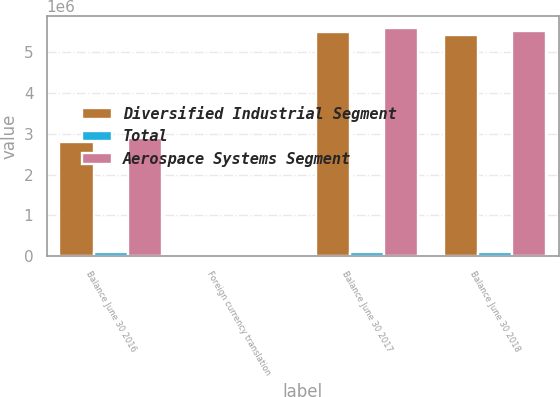Convert chart to OTSL. <chart><loc_0><loc_0><loc_500><loc_500><stacked_bar_chart><ecel><fcel>Balance June 30 2016<fcel>Foreign currency translation<fcel>Balance June 30 2017<fcel>Balance June 30 2018<nl><fcel>Diversified Industrial Segment<fcel>2.8044e+06<fcel>28962<fcel>5.48824e+06<fcel>5.40577e+06<nl><fcel>Total<fcel>98634<fcel>8<fcel>98642<fcel>98649<nl><fcel>Aerospace Systems Segment<fcel>2.90304e+06<fcel>28970<fcel>5.58688e+06<fcel>5.50442e+06<nl></chart> 